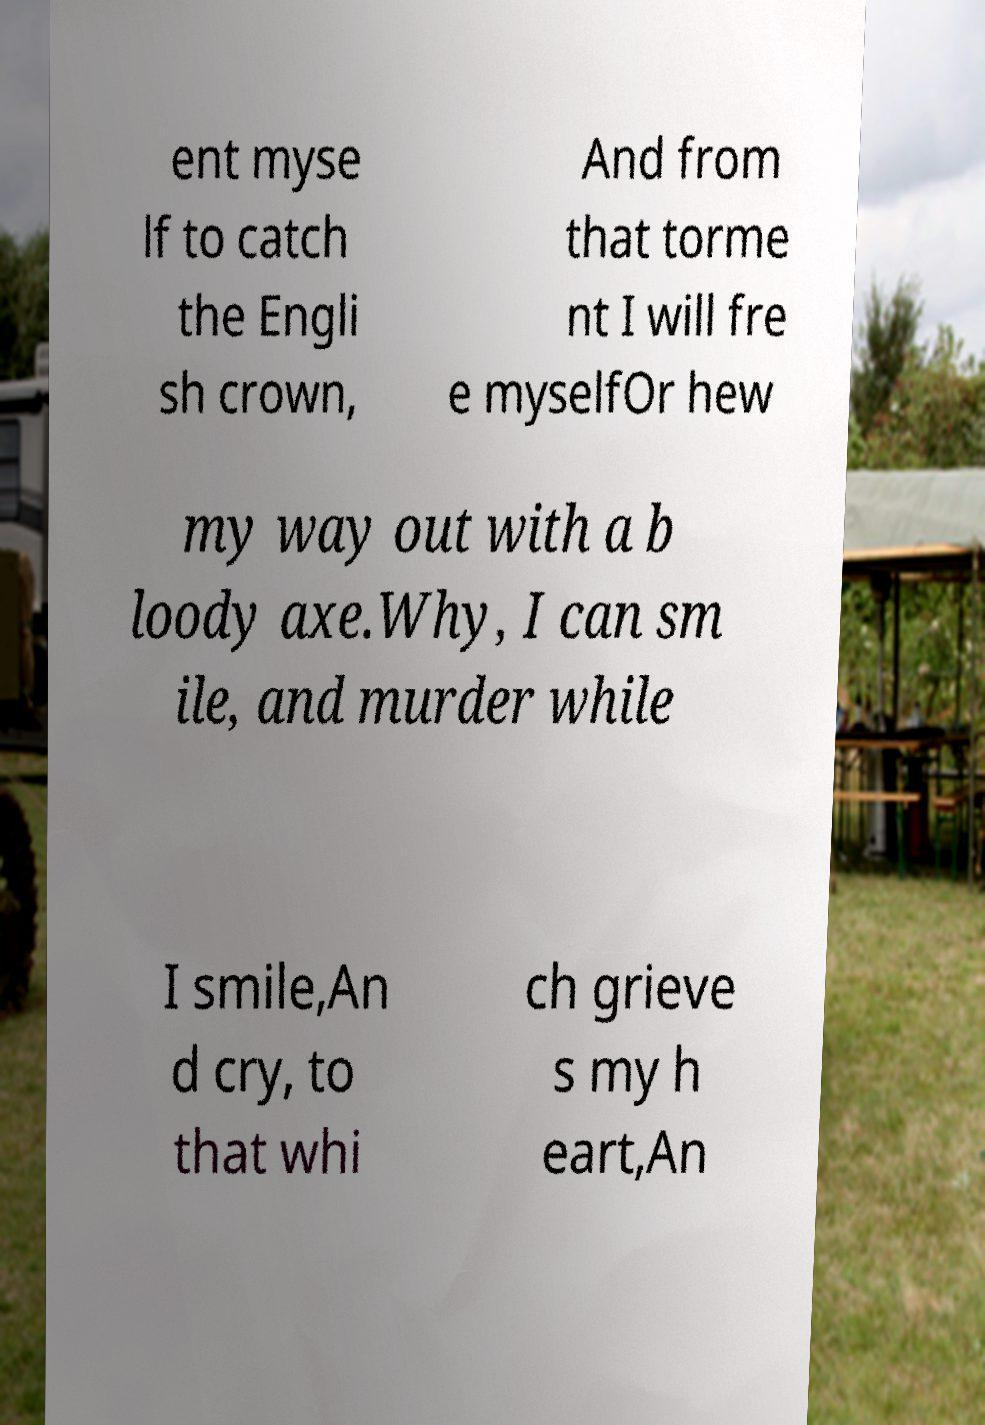Can you accurately transcribe the text from the provided image for me? ent myse lf to catch the Engli sh crown, And from that torme nt I will fre e myselfOr hew my way out with a b loody axe.Why, I can sm ile, and murder while I smile,An d cry, to that whi ch grieve s my h eart,An 